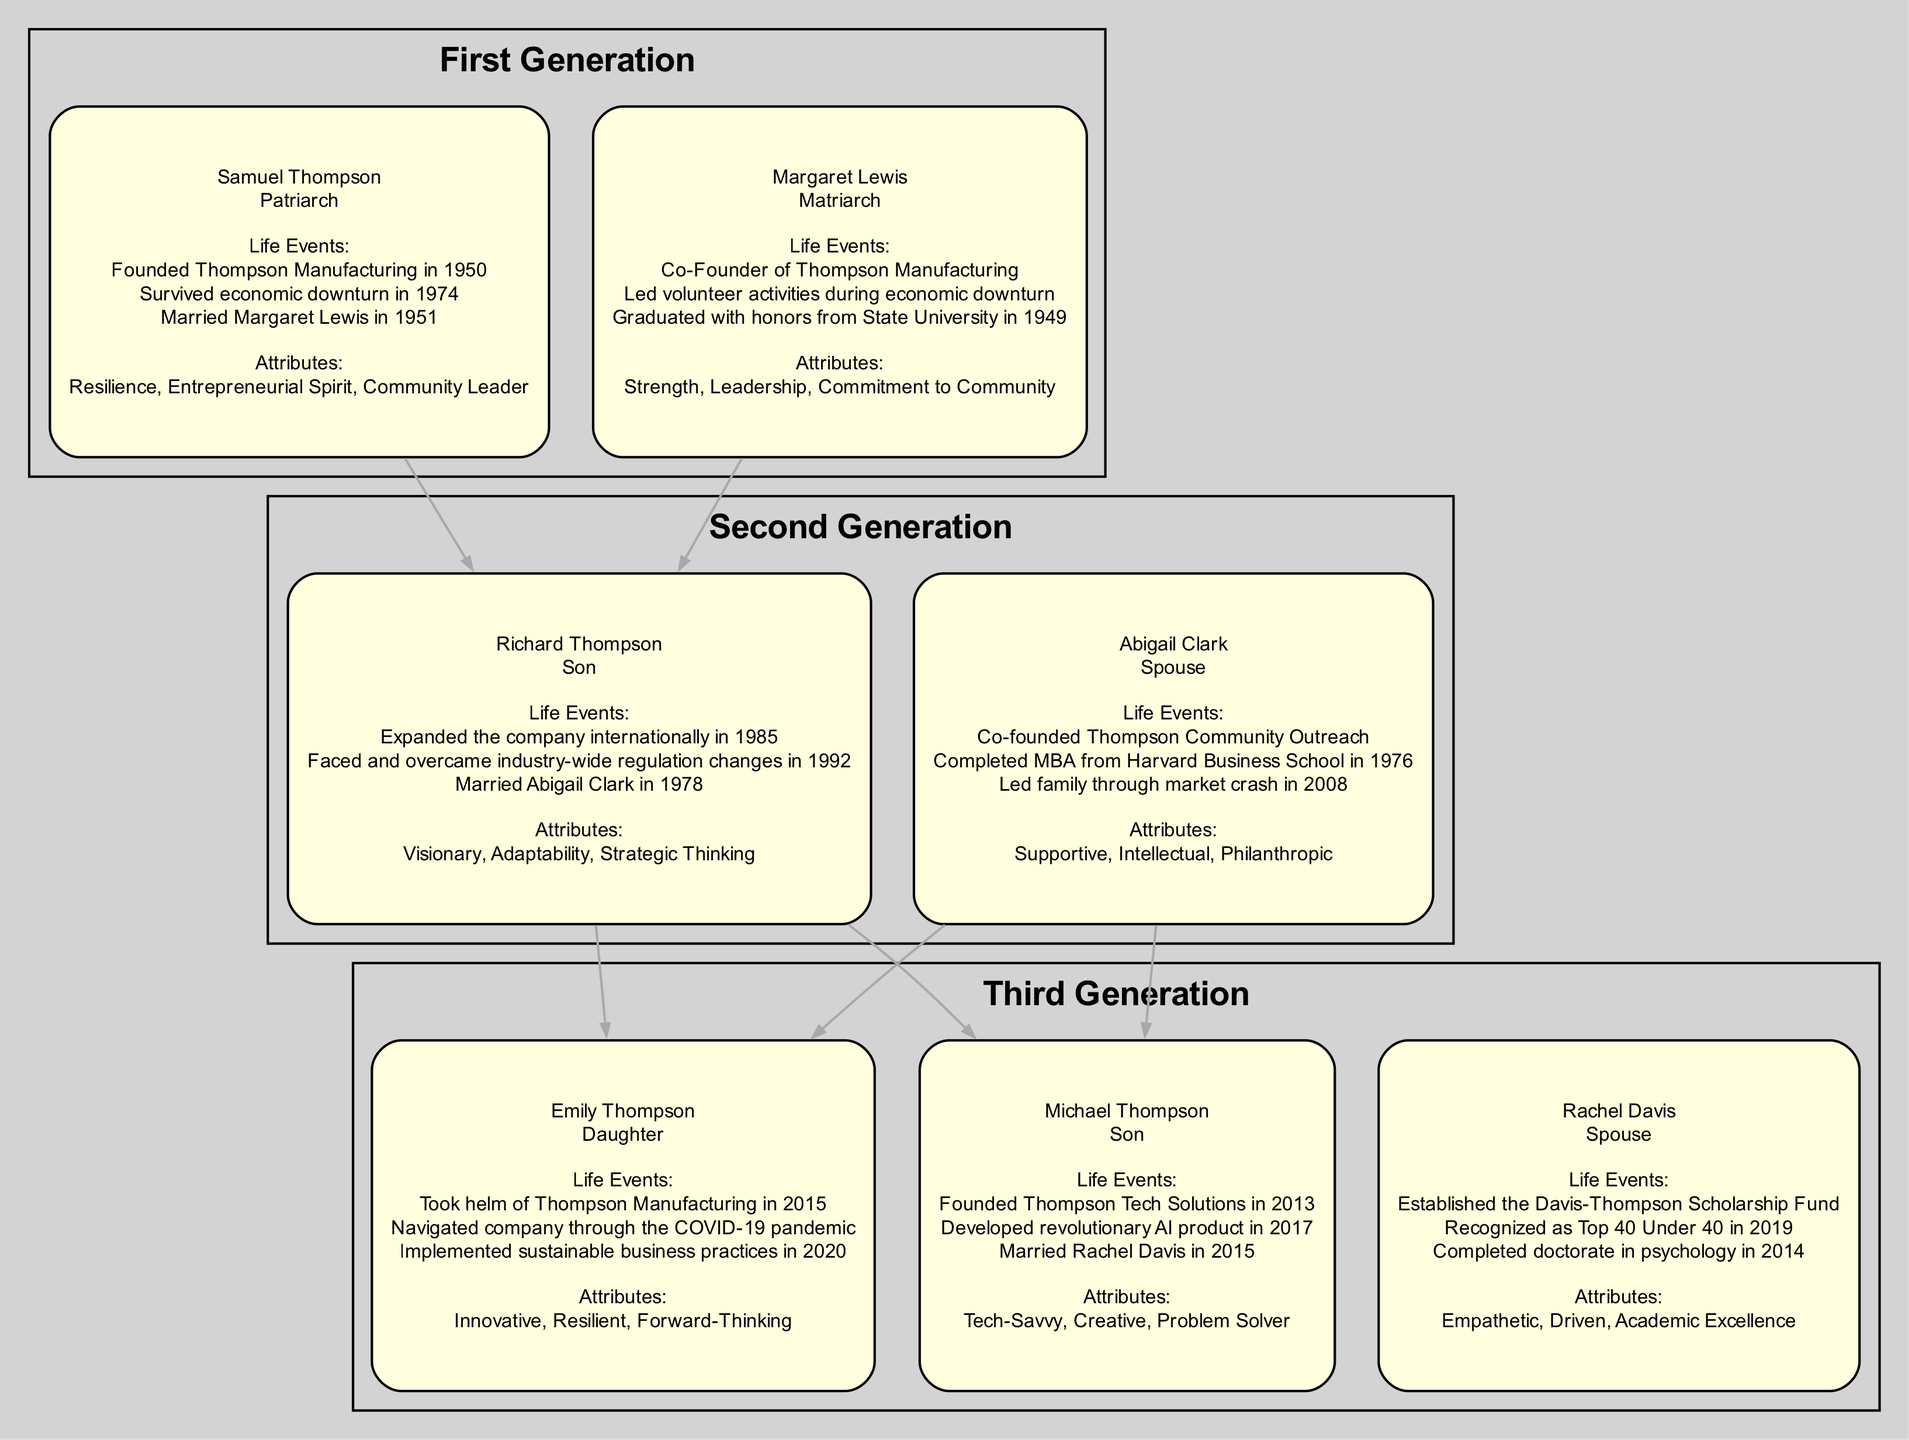What is the name of the patriarch in the family tree? The diagram clearly identifies Samuel Thompson as the patriarch in the first generation. His name is prominently displayed within the corresponding node for the first generation.
Answer: Samuel Thompson How many members are there in the second generation? The second generation includes two members: Richard Thompson and Abigail Clark. By counting the nodes listed under the second generation, we find two entries.
Answer: 2 Who is the spouse of Michael Thompson? According to the diagram, Michael Thompson is married to Rachel Davis, which is labeled in his node as well. This relationship is explicitly stated in the family tree layout.
Answer: Rachel Davis What life event did Emily Thompson implement in 2020? The diagram indicates that Emily Thompson implemented sustainable business practices in 2020. This specific event is listed under her life events, making it clear.
Answer: Implemented sustainable business practices Which generation faced the economic downturn in 1974? The first generation, represented by Samuel Thompson and Margaret Lewis, faced the economic downturn in 1974. This event is noted in Samuel's life events, showing that he survived it during his era.
Answer: First How did Abigail Clark contribute professionally in 2008? Abigail Clark led the family through the market crash in 2008, as mentioned in her life events. This demonstrates her role in professional crisis management for the family's business.
Answer: Led family through market crash Which member of the family founded a tech solutions company? Michael Thompson is identified in the third generation as the founder of Thompson Tech Solutions in 2013. This is specifically highlighted in his life events.
Answer: Michael Thompson Name one attribute of Margaret Lewis. One of the attributes listed for Margaret Lewis is 'Strength'. This is shown in the attributes section of her node within the first generation.
Answer: Strength What are the life events of Richard Thompson? Richard Thompson's life events include expanding the company internationally in 1985, facing industry-wide regulation changes in 1992, and marrying Abigail Clark in 1978. These events are specifically enumerated in his node.
Answer: Expanded the company internationally in 1985, faced regulation changes in 1992, married Abigail Clark in 1978 